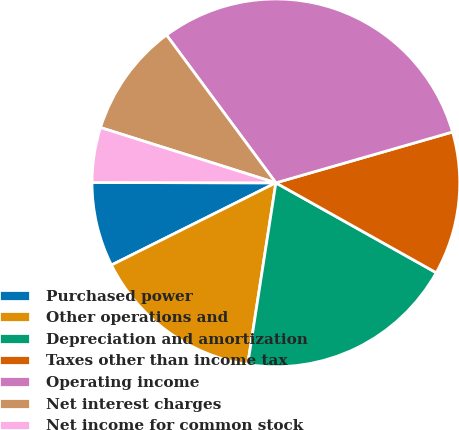Convert chart to OTSL. <chart><loc_0><loc_0><loc_500><loc_500><pie_chart><fcel>Purchased power<fcel>Other operations and<fcel>Depreciation and amortization<fcel>Taxes other than income tax<fcel>Operating income<fcel>Net interest charges<fcel>Net income for common stock<nl><fcel>7.41%<fcel>15.17%<fcel>19.32%<fcel>12.59%<fcel>30.68%<fcel>10.0%<fcel>4.83%<nl></chart> 